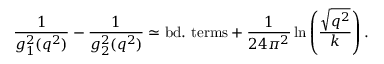Convert formula to latex. <formula><loc_0><loc_0><loc_500><loc_500>{ \frac { 1 } { g _ { 1 } ^ { 2 } ( q ^ { 2 } ) } } - { \frac { 1 } { g _ { 2 } ^ { 2 } ( q ^ { 2 } ) } } \simeq b d . t e r m s + { \frac { 1 } { 2 4 \pi ^ { 2 } } } \ln \left ( { \frac { \sqrt { q ^ { 2 } } } { k } } \right ) .</formula> 